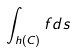Convert formula to latex. <formula><loc_0><loc_0><loc_500><loc_500>\int _ { h ( C ) } f d s</formula> 